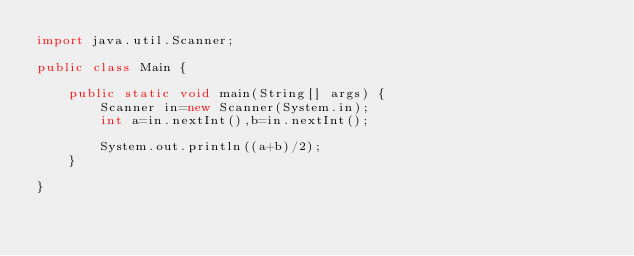<code> <loc_0><loc_0><loc_500><loc_500><_Java_>import java.util.Scanner;

public class Main {

	public static void main(String[] args) {
		Scanner in=new Scanner(System.in);
		int a=in.nextInt(),b=in.nextInt();
		
		System.out.println((a+b)/2);
	}

}

</code> 